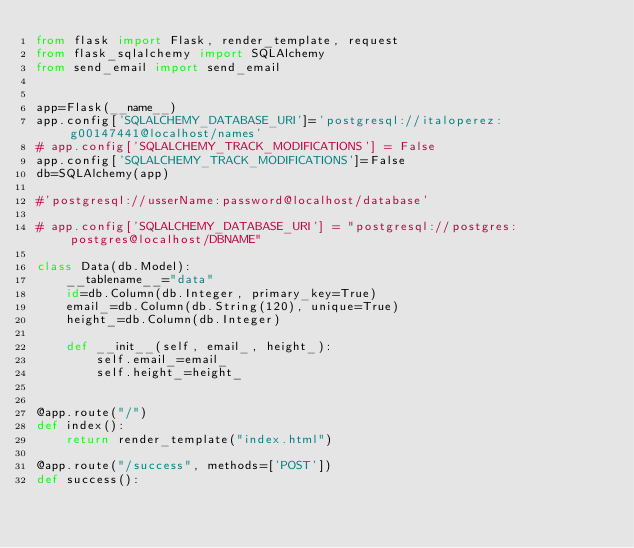<code> <loc_0><loc_0><loc_500><loc_500><_Python_>from flask import Flask, render_template, request
from flask_sqlalchemy import SQLAlchemy
from send_email import send_email


app=Flask(__name__)
app.config['SQLALCHEMY_DATABASE_URI']='postgresql://italoperez:g00147441@localhost/names'
# app.config['SQLALCHEMY_TRACK_MODIFICATIONS'] = False
app.config['SQLALCHEMY_TRACK_MODIFICATIONS']=False
db=SQLAlchemy(app)

#'postgresql://usserName:password@localhost/database'

# app.config['SQLALCHEMY_DATABASE_URI'] = "postgresql://postgres:postgres@localhost/DBNAME"

class Data(db.Model):
    __tablename__="data"
    id=db.Column(db.Integer, primary_key=True)
    email_=db.Column(db.String(120), unique=True)
    height_=db.Column(db.Integer)
    
    def __init__(self, email_, height_):
        self.email_=email_
        self.height_=height_


@app.route("/")
def index():
    return render_template("index.html")

@app.route("/success", methods=['POST'])
def success():</code> 